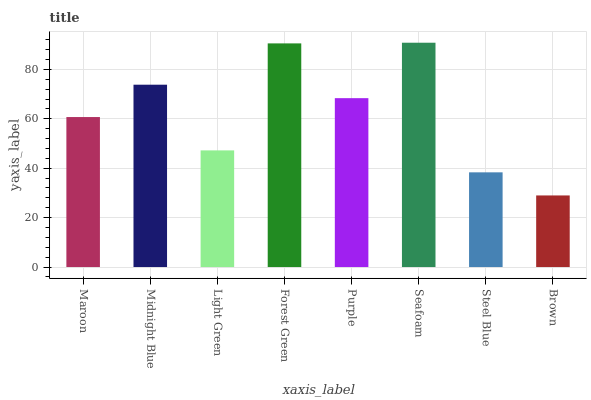Is Brown the minimum?
Answer yes or no. Yes. Is Seafoam the maximum?
Answer yes or no. Yes. Is Midnight Blue the minimum?
Answer yes or no. No. Is Midnight Blue the maximum?
Answer yes or no. No. Is Midnight Blue greater than Maroon?
Answer yes or no. Yes. Is Maroon less than Midnight Blue?
Answer yes or no. Yes. Is Maroon greater than Midnight Blue?
Answer yes or no. No. Is Midnight Blue less than Maroon?
Answer yes or no. No. Is Purple the high median?
Answer yes or no. Yes. Is Maroon the low median?
Answer yes or no. Yes. Is Steel Blue the high median?
Answer yes or no. No. Is Purple the low median?
Answer yes or no. No. 